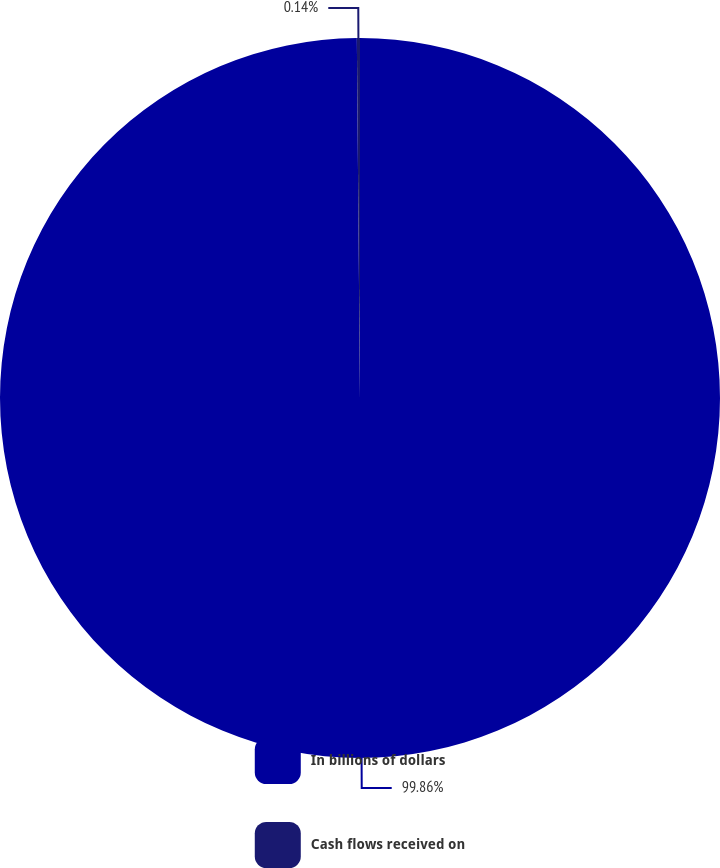Convert chart to OTSL. <chart><loc_0><loc_0><loc_500><loc_500><pie_chart><fcel>In billions of dollars<fcel>Cash flows received on<nl><fcel>99.86%<fcel>0.14%<nl></chart> 